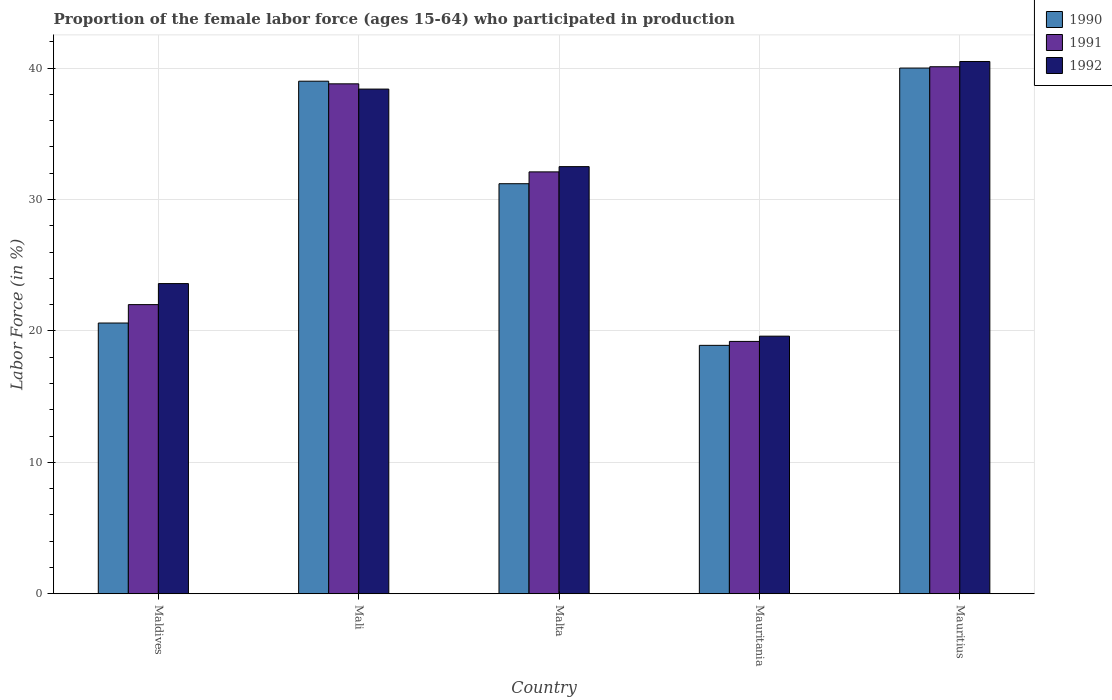Are the number of bars per tick equal to the number of legend labels?
Offer a very short reply. Yes. How many bars are there on the 5th tick from the left?
Your response must be concise. 3. What is the label of the 3rd group of bars from the left?
Make the answer very short. Malta. What is the proportion of the female labor force who participated in production in 1991 in Mali?
Offer a terse response. 38.8. Across all countries, what is the maximum proportion of the female labor force who participated in production in 1992?
Make the answer very short. 40.5. Across all countries, what is the minimum proportion of the female labor force who participated in production in 1991?
Your answer should be very brief. 19.2. In which country was the proportion of the female labor force who participated in production in 1991 maximum?
Ensure brevity in your answer.  Mauritius. In which country was the proportion of the female labor force who participated in production in 1991 minimum?
Offer a very short reply. Mauritania. What is the total proportion of the female labor force who participated in production in 1992 in the graph?
Offer a terse response. 154.6. What is the difference between the proportion of the female labor force who participated in production in 1991 in Mali and that in Mauritania?
Offer a very short reply. 19.6. What is the difference between the proportion of the female labor force who participated in production in 1992 in Mauritania and the proportion of the female labor force who participated in production in 1990 in Maldives?
Offer a very short reply. -1. What is the average proportion of the female labor force who participated in production in 1990 per country?
Your answer should be very brief. 29.94. What is the difference between the proportion of the female labor force who participated in production of/in 1990 and proportion of the female labor force who participated in production of/in 1992 in Mali?
Give a very brief answer. 0.6. What is the ratio of the proportion of the female labor force who participated in production in 1991 in Malta to that in Mauritius?
Your answer should be very brief. 0.8. Is the proportion of the female labor force who participated in production in 1990 in Malta less than that in Mauritania?
Provide a succinct answer. No. Is the difference between the proportion of the female labor force who participated in production in 1990 in Maldives and Mauritius greater than the difference between the proportion of the female labor force who participated in production in 1992 in Maldives and Mauritius?
Provide a succinct answer. No. What is the difference between the highest and the second highest proportion of the female labor force who participated in production in 1990?
Your answer should be compact. 8.8. What is the difference between the highest and the lowest proportion of the female labor force who participated in production in 1990?
Your response must be concise. 21.1. In how many countries, is the proportion of the female labor force who participated in production in 1991 greater than the average proportion of the female labor force who participated in production in 1991 taken over all countries?
Provide a short and direct response. 3. What does the 3rd bar from the left in Maldives represents?
Give a very brief answer. 1992. Are all the bars in the graph horizontal?
Keep it short and to the point. No. Where does the legend appear in the graph?
Give a very brief answer. Top right. How many legend labels are there?
Your answer should be compact. 3. What is the title of the graph?
Offer a very short reply. Proportion of the female labor force (ages 15-64) who participated in production. What is the Labor Force (in %) in 1990 in Maldives?
Offer a very short reply. 20.6. What is the Labor Force (in %) of 1992 in Maldives?
Your response must be concise. 23.6. What is the Labor Force (in %) in 1991 in Mali?
Make the answer very short. 38.8. What is the Labor Force (in %) of 1992 in Mali?
Make the answer very short. 38.4. What is the Labor Force (in %) of 1990 in Malta?
Your response must be concise. 31.2. What is the Labor Force (in %) of 1991 in Malta?
Provide a short and direct response. 32.1. What is the Labor Force (in %) of 1992 in Malta?
Offer a very short reply. 32.5. What is the Labor Force (in %) of 1990 in Mauritania?
Make the answer very short. 18.9. What is the Labor Force (in %) in 1991 in Mauritania?
Make the answer very short. 19.2. What is the Labor Force (in %) in 1992 in Mauritania?
Keep it short and to the point. 19.6. What is the Labor Force (in %) of 1990 in Mauritius?
Your response must be concise. 40. What is the Labor Force (in %) of 1991 in Mauritius?
Your answer should be compact. 40.1. What is the Labor Force (in %) in 1992 in Mauritius?
Provide a short and direct response. 40.5. Across all countries, what is the maximum Labor Force (in %) of 1990?
Your answer should be compact. 40. Across all countries, what is the maximum Labor Force (in %) in 1991?
Make the answer very short. 40.1. Across all countries, what is the maximum Labor Force (in %) in 1992?
Offer a very short reply. 40.5. Across all countries, what is the minimum Labor Force (in %) in 1990?
Keep it short and to the point. 18.9. Across all countries, what is the minimum Labor Force (in %) in 1991?
Keep it short and to the point. 19.2. Across all countries, what is the minimum Labor Force (in %) of 1992?
Ensure brevity in your answer.  19.6. What is the total Labor Force (in %) in 1990 in the graph?
Provide a short and direct response. 149.7. What is the total Labor Force (in %) in 1991 in the graph?
Your response must be concise. 152.2. What is the total Labor Force (in %) of 1992 in the graph?
Make the answer very short. 154.6. What is the difference between the Labor Force (in %) in 1990 in Maldives and that in Mali?
Make the answer very short. -18.4. What is the difference between the Labor Force (in %) in 1991 in Maldives and that in Mali?
Provide a succinct answer. -16.8. What is the difference between the Labor Force (in %) of 1992 in Maldives and that in Mali?
Keep it short and to the point. -14.8. What is the difference between the Labor Force (in %) in 1990 in Maldives and that in Malta?
Ensure brevity in your answer.  -10.6. What is the difference between the Labor Force (in %) in 1992 in Maldives and that in Malta?
Ensure brevity in your answer.  -8.9. What is the difference between the Labor Force (in %) in 1990 in Maldives and that in Mauritania?
Give a very brief answer. 1.7. What is the difference between the Labor Force (in %) of 1990 in Maldives and that in Mauritius?
Make the answer very short. -19.4. What is the difference between the Labor Force (in %) of 1991 in Maldives and that in Mauritius?
Ensure brevity in your answer.  -18.1. What is the difference between the Labor Force (in %) in 1992 in Maldives and that in Mauritius?
Ensure brevity in your answer.  -16.9. What is the difference between the Labor Force (in %) of 1990 in Mali and that in Malta?
Offer a terse response. 7.8. What is the difference between the Labor Force (in %) in 1991 in Mali and that in Malta?
Your response must be concise. 6.7. What is the difference between the Labor Force (in %) in 1990 in Mali and that in Mauritania?
Provide a short and direct response. 20.1. What is the difference between the Labor Force (in %) of 1991 in Mali and that in Mauritania?
Give a very brief answer. 19.6. What is the difference between the Labor Force (in %) in 1990 in Mali and that in Mauritius?
Offer a very short reply. -1. What is the difference between the Labor Force (in %) of 1992 in Mali and that in Mauritius?
Offer a terse response. -2.1. What is the difference between the Labor Force (in %) of 1990 in Malta and that in Mauritania?
Your response must be concise. 12.3. What is the difference between the Labor Force (in %) of 1991 in Malta and that in Mauritania?
Give a very brief answer. 12.9. What is the difference between the Labor Force (in %) in 1992 in Malta and that in Mauritania?
Your answer should be very brief. 12.9. What is the difference between the Labor Force (in %) in 1992 in Malta and that in Mauritius?
Offer a very short reply. -8. What is the difference between the Labor Force (in %) in 1990 in Mauritania and that in Mauritius?
Provide a succinct answer. -21.1. What is the difference between the Labor Force (in %) of 1991 in Mauritania and that in Mauritius?
Ensure brevity in your answer.  -20.9. What is the difference between the Labor Force (in %) in 1992 in Mauritania and that in Mauritius?
Give a very brief answer. -20.9. What is the difference between the Labor Force (in %) in 1990 in Maldives and the Labor Force (in %) in 1991 in Mali?
Offer a terse response. -18.2. What is the difference between the Labor Force (in %) in 1990 in Maldives and the Labor Force (in %) in 1992 in Mali?
Keep it short and to the point. -17.8. What is the difference between the Labor Force (in %) in 1991 in Maldives and the Labor Force (in %) in 1992 in Mali?
Offer a very short reply. -16.4. What is the difference between the Labor Force (in %) of 1991 in Maldives and the Labor Force (in %) of 1992 in Mauritania?
Offer a very short reply. 2.4. What is the difference between the Labor Force (in %) of 1990 in Maldives and the Labor Force (in %) of 1991 in Mauritius?
Make the answer very short. -19.5. What is the difference between the Labor Force (in %) in 1990 in Maldives and the Labor Force (in %) in 1992 in Mauritius?
Provide a succinct answer. -19.9. What is the difference between the Labor Force (in %) in 1991 in Maldives and the Labor Force (in %) in 1992 in Mauritius?
Provide a succinct answer. -18.5. What is the difference between the Labor Force (in %) in 1991 in Mali and the Labor Force (in %) in 1992 in Malta?
Provide a succinct answer. 6.3. What is the difference between the Labor Force (in %) in 1990 in Mali and the Labor Force (in %) in 1991 in Mauritania?
Give a very brief answer. 19.8. What is the difference between the Labor Force (in %) of 1990 in Mali and the Labor Force (in %) of 1992 in Mauritania?
Your answer should be very brief. 19.4. What is the difference between the Labor Force (in %) of 1991 in Mali and the Labor Force (in %) of 1992 in Mauritania?
Your response must be concise. 19.2. What is the difference between the Labor Force (in %) in 1990 in Mali and the Labor Force (in %) in 1992 in Mauritius?
Your answer should be compact. -1.5. What is the difference between the Labor Force (in %) in 1991 in Mali and the Labor Force (in %) in 1992 in Mauritius?
Offer a terse response. -1.7. What is the difference between the Labor Force (in %) of 1991 in Malta and the Labor Force (in %) of 1992 in Mauritania?
Ensure brevity in your answer.  12.5. What is the difference between the Labor Force (in %) in 1990 in Malta and the Labor Force (in %) in 1991 in Mauritius?
Provide a succinct answer. -8.9. What is the difference between the Labor Force (in %) of 1990 in Malta and the Labor Force (in %) of 1992 in Mauritius?
Provide a short and direct response. -9.3. What is the difference between the Labor Force (in %) in 1991 in Malta and the Labor Force (in %) in 1992 in Mauritius?
Give a very brief answer. -8.4. What is the difference between the Labor Force (in %) in 1990 in Mauritania and the Labor Force (in %) in 1991 in Mauritius?
Offer a very short reply. -21.2. What is the difference between the Labor Force (in %) of 1990 in Mauritania and the Labor Force (in %) of 1992 in Mauritius?
Provide a short and direct response. -21.6. What is the difference between the Labor Force (in %) in 1991 in Mauritania and the Labor Force (in %) in 1992 in Mauritius?
Your response must be concise. -21.3. What is the average Labor Force (in %) of 1990 per country?
Your answer should be very brief. 29.94. What is the average Labor Force (in %) of 1991 per country?
Give a very brief answer. 30.44. What is the average Labor Force (in %) of 1992 per country?
Give a very brief answer. 30.92. What is the difference between the Labor Force (in %) of 1990 and Labor Force (in %) of 1992 in Maldives?
Make the answer very short. -3. What is the difference between the Labor Force (in %) of 1991 and Labor Force (in %) of 1992 in Maldives?
Offer a very short reply. -1.6. What is the difference between the Labor Force (in %) in 1990 and Labor Force (in %) in 1991 in Mali?
Offer a terse response. 0.2. What is the difference between the Labor Force (in %) in 1991 and Labor Force (in %) in 1992 in Mali?
Make the answer very short. 0.4. What is the difference between the Labor Force (in %) of 1990 and Labor Force (in %) of 1992 in Malta?
Keep it short and to the point. -1.3. What is the difference between the Labor Force (in %) in 1991 and Labor Force (in %) in 1992 in Malta?
Provide a short and direct response. -0.4. What is the difference between the Labor Force (in %) in 1990 and Labor Force (in %) in 1992 in Mauritania?
Your answer should be compact. -0.7. What is the difference between the Labor Force (in %) in 1991 and Labor Force (in %) in 1992 in Mauritania?
Your response must be concise. -0.4. What is the ratio of the Labor Force (in %) in 1990 in Maldives to that in Mali?
Offer a terse response. 0.53. What is the ratio of the Labor Force (in %) in 1991 in Maldives to that in Mali?
Offer a terse response. 0.57. What is the ratio of the Labor Force (in %) of 1992 in Maldives to that in Mali?
Offer a terse response. 0.61. What is the ratio of the Labor Force (in %) in 1990 in Maldives to that in Malta?
Provide a short and direct response. 0.66. What is the ratio of the Labor Force (in %) in 1991 in Maldives to that in Malta?
Your answer should be compact. 0.69. What is the ratio of the Labor Force (in %) of 1992 in Maldives to that in Malta?
Ensure brevity in your answer.  0.73. What is the ratio of the Labor Force (in %) in 1990 in Maldives to that in Mauritania?
Provide a succinct answer. 1.09. What is the ratio of the Labor Force (in %) in 1991 in Maldives to that in Mauritania?
Provide a short and direct response. 1.15. What is the ratio of the Labor Force (in %) in 1992 in Maldives to that in Mauritania?
Your answer should be very brief. 1.2. What is the ratio of the Labor Force (in %) of 1990 in Maldives to that in Mauritius?
Give a very brief answer. 0.52. What is the ratio of the Labor Force (in %) of 1991 in Maldives to that in Mauritius?
Your response must be concise. 0.55. What is the ratio of the Labor Force (in %) of 1992 in Maldives to that in Mauritius?
Offer a very short reply. 0.58. What is the ratio of the Labor Force (in %) in 1990 in Mali to that in Malta?
Give a very brief answer. 1.25. What is the ratio of the Labor Force (in %) of 1991 in Mali to that in Malta?
Give a very brief answer. 1.21. What is the ratio of the Labor Force (in %) of 1992 in Mali to that in Malta?
Ensure brevity in your answer.  1.18. What is the ratio of the Labor Force (in %) of 1990 in Mali to that in Mauritania?
Provide a succinct answer. 2.06. What is the ratio of the Labor Force (in %) in 1991 in Mali to that in Mauritania?
Your response must be concise. 2.02. What is the ratio of the Labor Force (in %) of 1992 in Mali to that in Mauritania?
Offer a very short reply. 1.96. What is the ratio of the Labor Force (in %) of 1991 in Mali to that in Mauritius?
Your response must be concise. 0.97. What is the ratio of the Labor Force (in %) of 1992 in Mali to that in Mauritius?
Provide a succinct answer. 0.95. What is the ratio of the Labor Force (in %) in 1990 in Malta to that in Mauritania?
Keep it short and to the point. 1.65. What is the ratio of the Labor Force (in %) in 1991 in Malta to that in Mauritania?
Make the answer very short. 1.67. What is the ratio of the Labor Force (in %) of 1992 in Malta to that in Mauritania?
Ensure brevity in your answer.  1.66. What is the ratio of the Labor Force (in %) in 1990 in Malta to that in Mauritius?
Offer a terse response. 0.78. What is the ratio of the Labor Force (in %) in 1991 in Malta to that in Mauritius?
Your answer should be very brief. 0.8. What is the ratio of the Labor Force (in %) in 1992 in Malta to that in Mauritius?
Make the answer very short. 0.8. What is the ratio of the Labor Force (in %) of 1990 in Mauritania to that in Mauritius?
Keep it short and to the point. 0.47. What is the ratio of the Labor Force (in %) of 1991 in Mauritania to that in Mauritius?
Provide a succinct answer. 0.48. What is the ratio of the Labor Force (in %) of 1992 in Mauritania to that in Mauritius?
Ensure brevity in your answer.  0.48. What is the difference between the highest and the second highest Labor Force (in %) in 1990?
Offer a very short reply. 1. What is the difference between the highest and the lowest Labor Force (in %) of 1990?
Your answer should be compact. 21.1. What is the difference between the highest and the lowest Labor Force (in %) in 1991?
Make the answer very short. 20.9. What is the difference between the highest and the lowest Labor Force (in %) in 1992?
Keep it short and to the point. 20.9. 